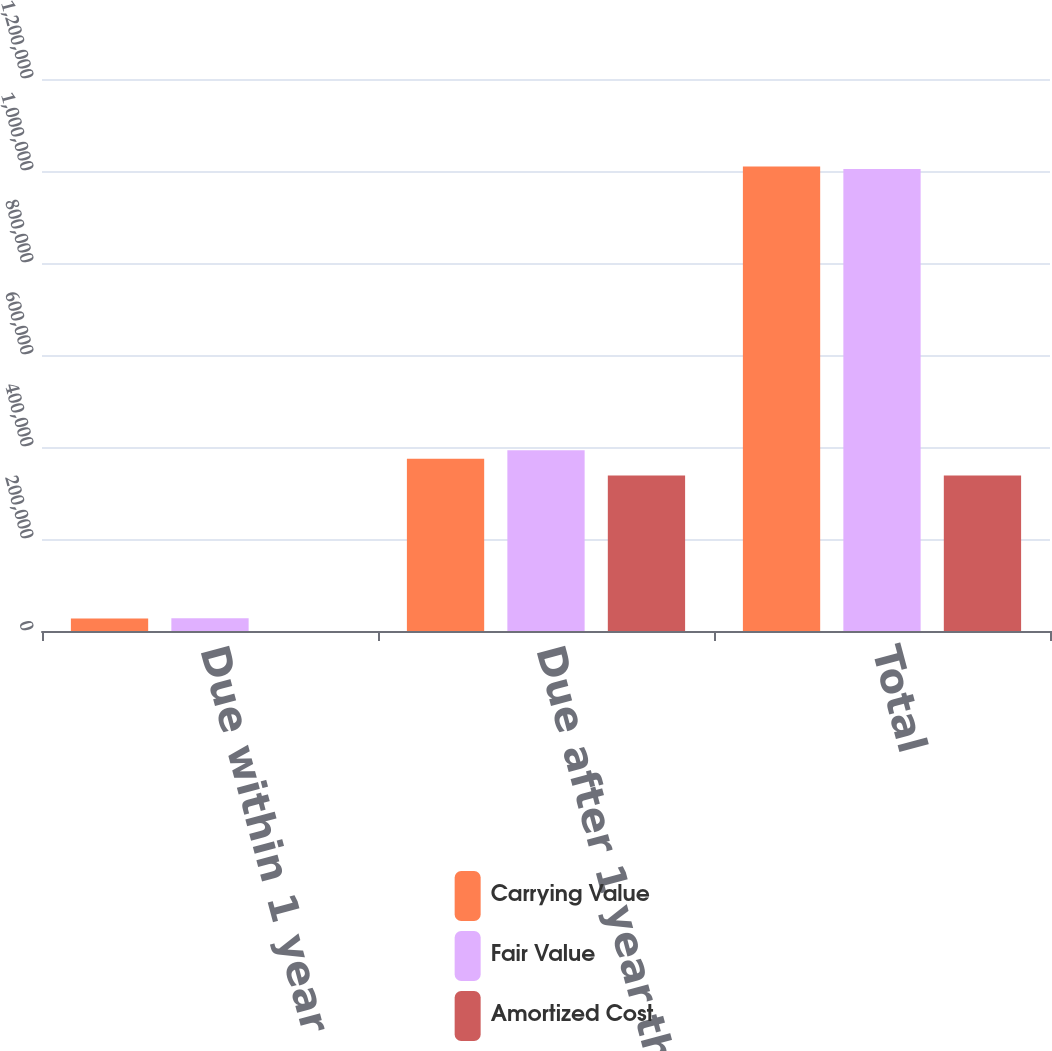Convert chart. <chart><loc_0><loc_0><loc_500><loc_500><stacked_bar_chart><ecel><fcel>Due within 1 year<fcel>Due after 1 year through 5<fcel>Total<nl><fcel>Carrying Value<fcel>27420<fcel>374519<fcel>1.00966e+06<nl><fcel>Fair Value<fcel>27905<fcel>393114<fcel>1.00433e+06<nl><fcel>Amortized Cost<fcel>19<fcel>337778<fcel>337797<nl></chart> 